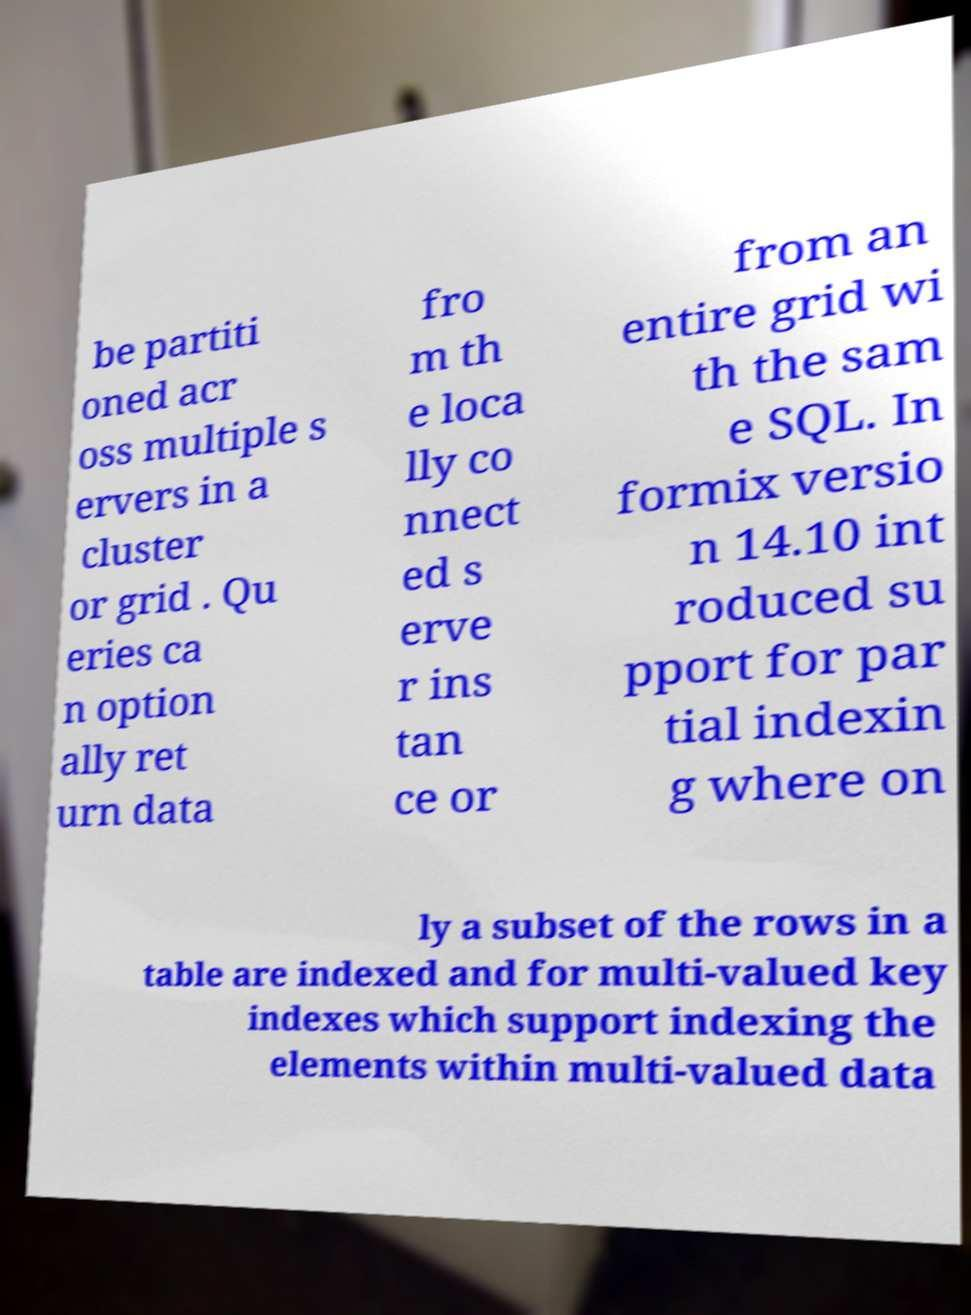I need the written content from this picture converted into text. Can you do that? be partiti oned acr oss multiple s ervers in a cluster or grid . Qu eries ca n option ally ret urn data fro m th e loca lly co nnect ed s erve r ins tan ce or from an entire grid wi th the sam e SQL. In formix versio n 14.10 int roduced su pport for par tial indexin g where on ly a subset of the rows in a table are indexed and for multi-valued key indexes which support indexing the elements within multi-valued data 